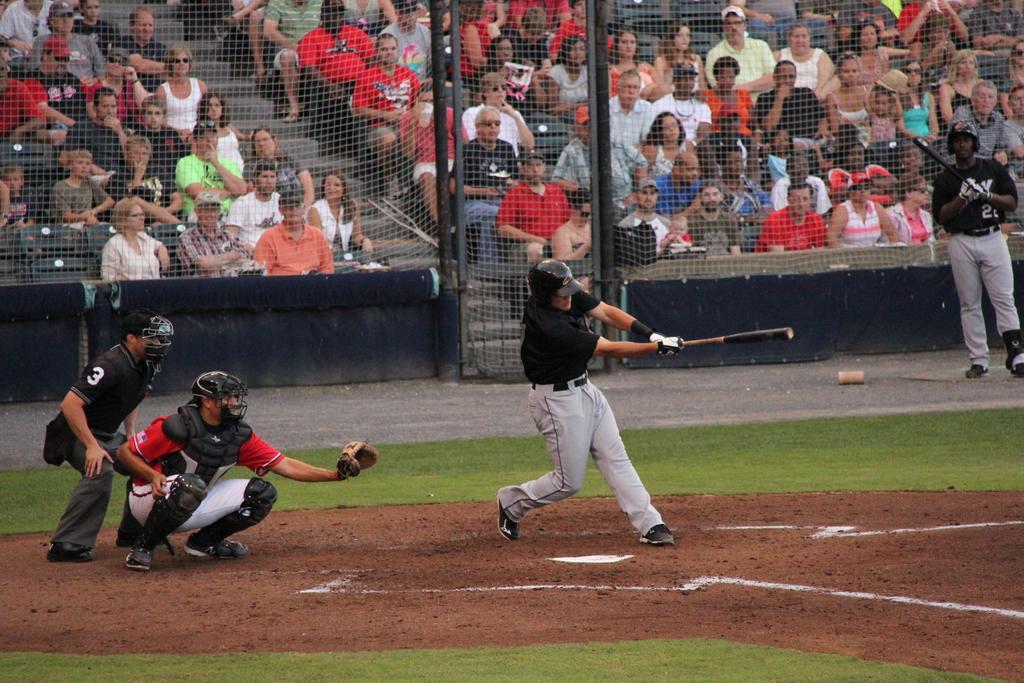Can you describe this image briefly? In this image we can see players are playing baseball on the ground. Background of the image, fencing is there. Behind the fencing, people are sitting in the sitting area of the ground and watching the game. 